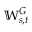<formula> <loc_0><loc_0><loc_500><loc_500>\mathbb { W } _ { s , t } ^ { G }</formula> 